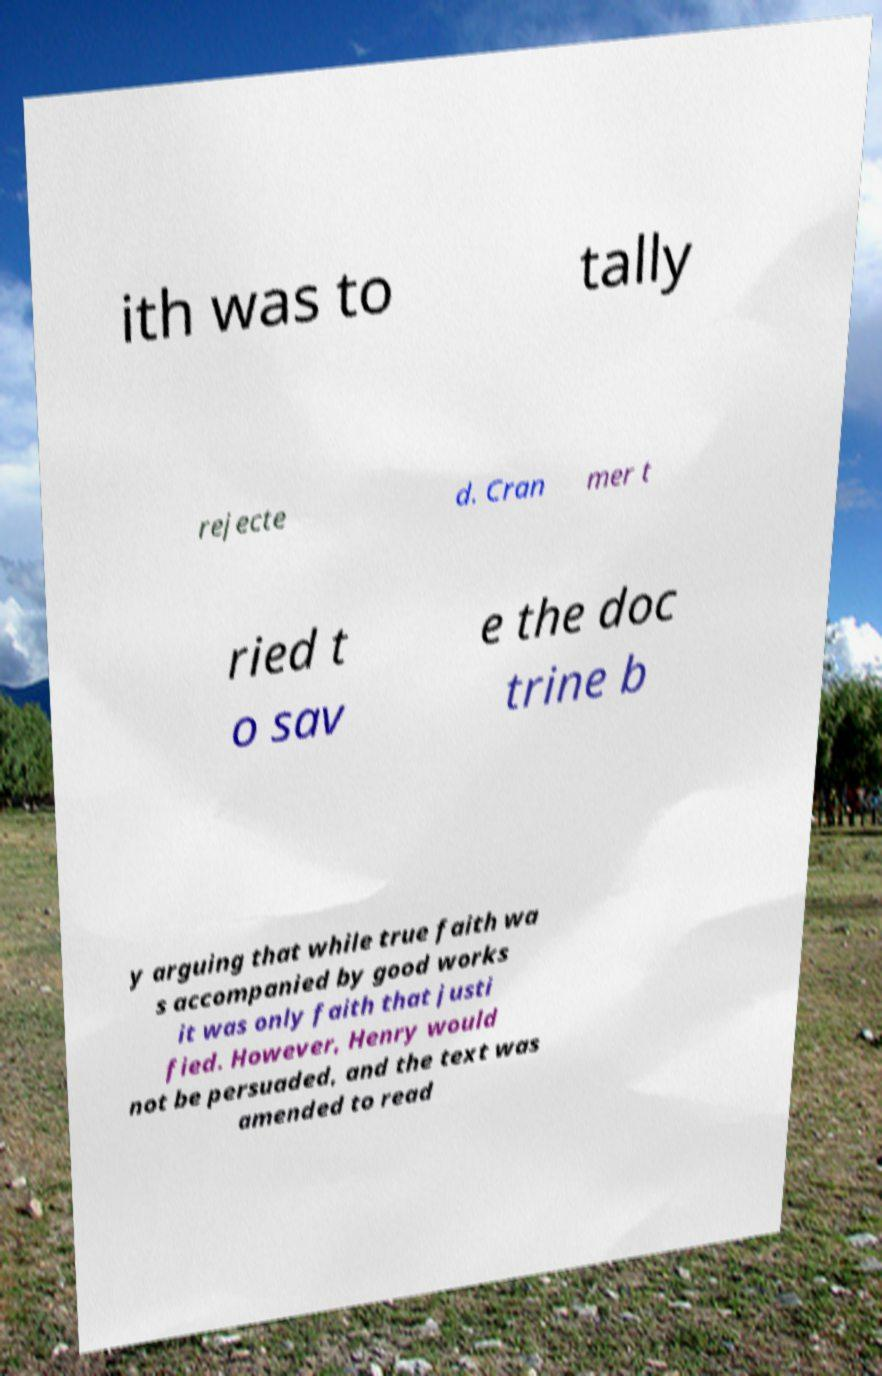Please read and relay the text visible in this image. What does it say? ith was to tally rejecte d. Cran mer t ried t o sav e the doc trine b y arguing that while true faith wa s accompanied by good works it was only faith that justi fied. However, Henry would not be persuaded, and the text was amended to read 